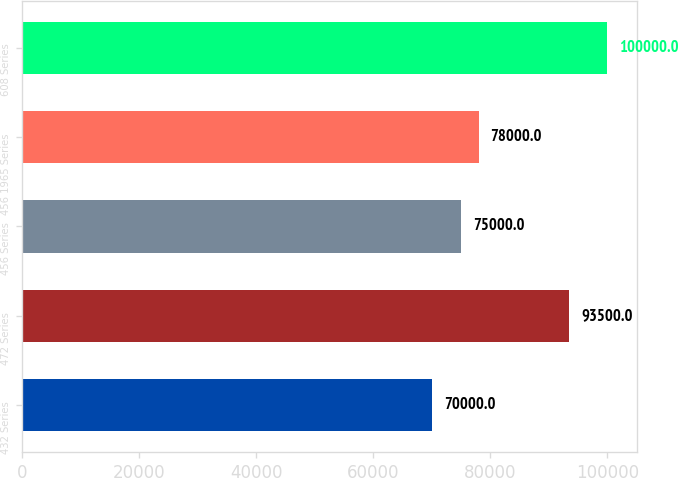Convert chart to OTSL. <chart><loc_0><loc_0><loc_500><loc_500><bar_chart><fcel>432 Series<fcel>472 Series<fcel>456 Series<fcel>456 1965 Series<fcel>608 Series<nl><fcel>70000<fcel>93500<fcel>75000<fcel>78000<fcel>100000<nl></chart> 